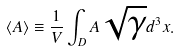Convert formula to latex. <formula><loc_0><loc_0><loc_500><loc_500>\langle { A } \rangle \equiv \frac { 1 } { V } \int _ { D } A \sqrt { \gamma } d ^ { 3 } x .</formula> 